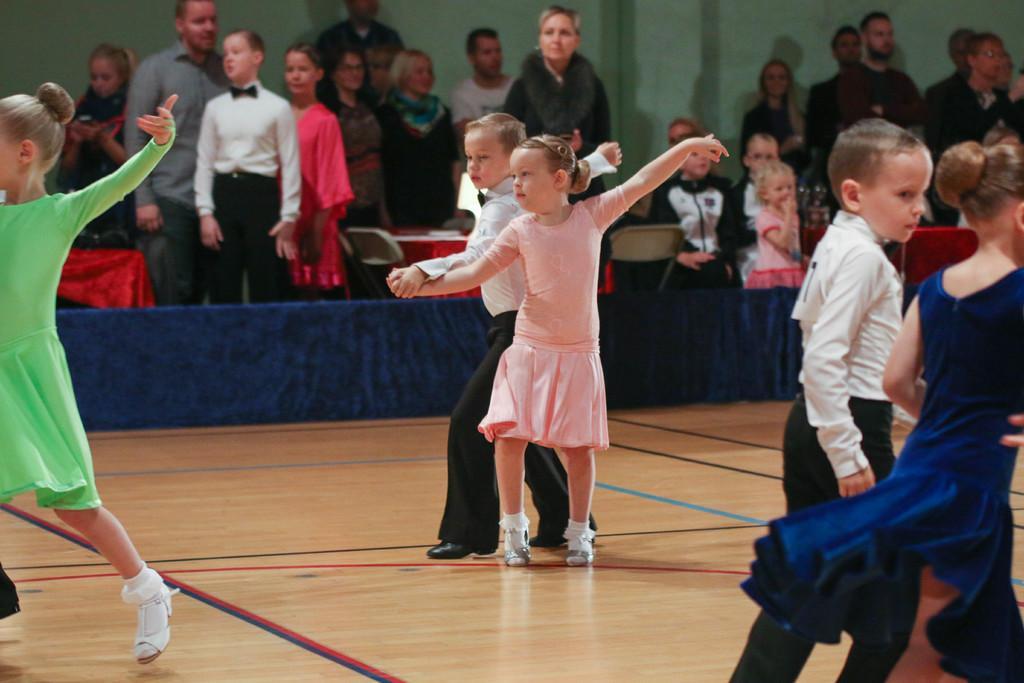In one or two sentences, can you explain what this image depicts? This image is taken indoors. At the bottom of the image there is a floor. In the background there is a wall. Many people are standing on the floor. There are a few tables with tablecloths and there are few empty chairs. In the middle of the image a girl and a boy while performing. On the right side of the image a girl and a boy are walking on floor. On the right left side of the image there is a girl. 